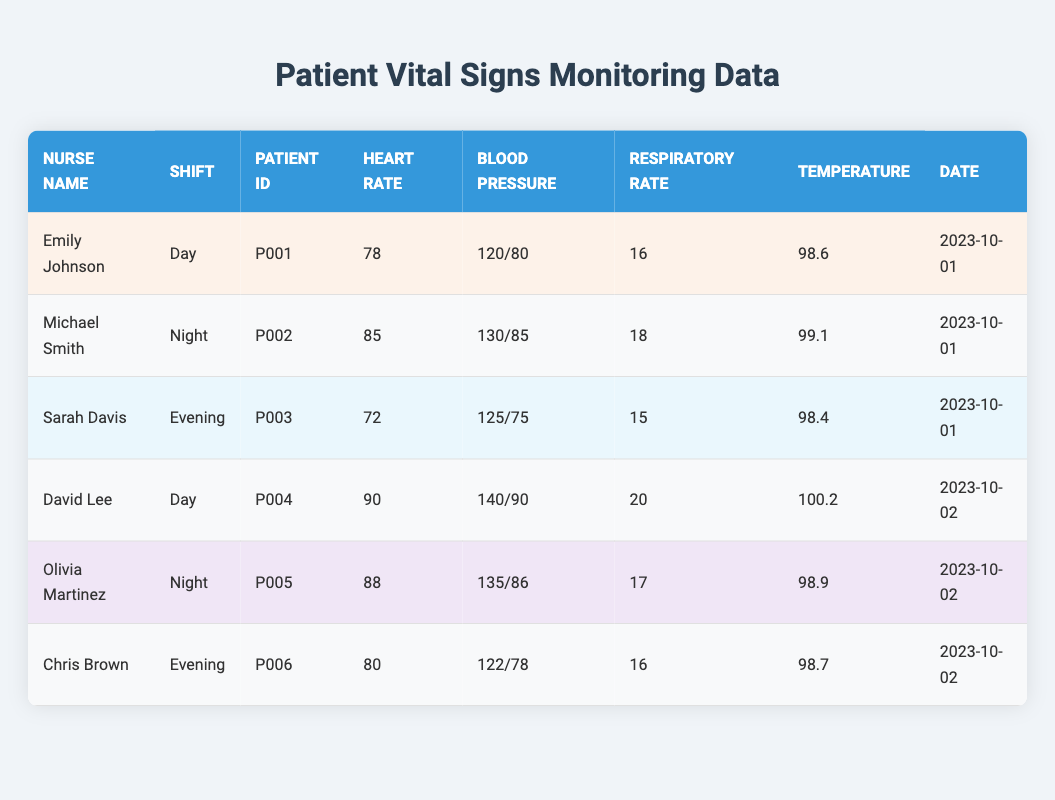What is the heart rate recorded by Emily Johnson for patient P001? Emily Johnson's row shows the heart rate of patient P001 is 78.
Answer: 78 What was the respiratory rate for Michael Smith's shift at night? Michael Smith's row indicates a respiratory rate of 18.
Answer: 18 Which nurse recorded a temperature above 100 degrees? Checking each row, David Lee's temperature is 100.2, which is above 100 degrees, while others are not.
Answer: Yes What is the average heart rate of patients monitored by each nurse in the data? The heart rates of each patient are Emily Johnson (78), Michael Smith (85), Sarah Davis (72), David Lee (90), Olivia Martinez (88), Chris Brown (80). Summing these gives 78 + 85 + 72 + 90 + 88 + 80 = 493. There are 6 patients, so the average heart rate is 493 / 6 = 82.17.
Answer: 82.17 Was Olivia Martinez's blood pressure higher than David Lee's? Comparing both nurse's blood pressure, Olivia Martinez has 135/86 and David Lee has 140/90. Both systolic values are higher for David Lee, so NO.
Answer: No Which shift had the highest recorded heart rate? Looking at the heart rates for each shift: Day (78, 90), Night (85, 88), Evening (72, 80), the highest is 90 from David Lee on Day shift.
Answer: Day What temperature did Chris Brown record? Referring to Chris Brown’s row, he recorded a temperature of 98.7 degrees.
Answer: 98.7 How many patients had a respiratory rate of 16 or lower? Checking the respiratory rates: Emily Johnson 16, Sarah Davis 15, Chris Brown 16, therefore the total is 3 patients with 16 or lower.
Answer: 3 What is the difference in blood pressure between David Lee and Olivia Martinez? David Lee's blood pressure is 140/90, and Olivia Martinez's is 135/86. The systolic pressure difference is 140 - 135 = 5, and the diastolic is 90 - 86 = 4.
Answer: 5/4 Was there a patient with a lower heart rate than 75? Looking in the heart rates column, the lowest recorded heart rate is 72 (Sarah Davis), yes, so a patient did have a heart rate below 75.
Answer: Yes 